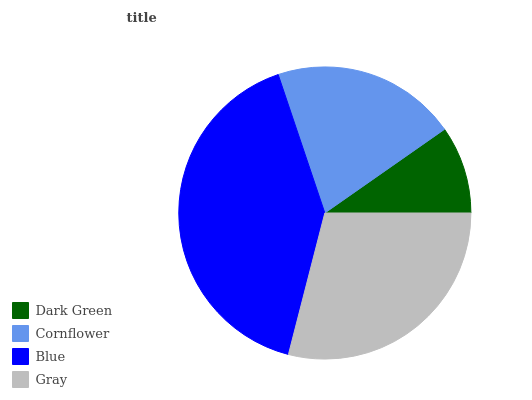Is Dark Green the minimum?
Answer yes or no. Yes. Is Blue the maximum?
Answer yes or no. Yes. Is Cornflower the minimum?
Answer yes or no. No. Is Cornflower the maximum?
Answer yes or no. No. Is Cornflower greater than Dark Green?
Answer yes or no. Yes. Is Dark Green less than Cornflower?
Answer yes or no. Yes. Is Dark Green greater than Cornflower?
Answer yes or no. No. Is Cornflower less than Dark Green?
Answer yes or no. No. Is Gray the high median?
Answer yes or no. Yes. Is Cornflower the low median?
Answer yes or no. Yes. Is Dark Green the high median?
Answer yes or no. No. Is Blue the low median?
Answer yes or no. No. 